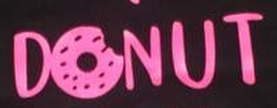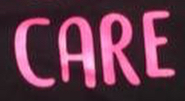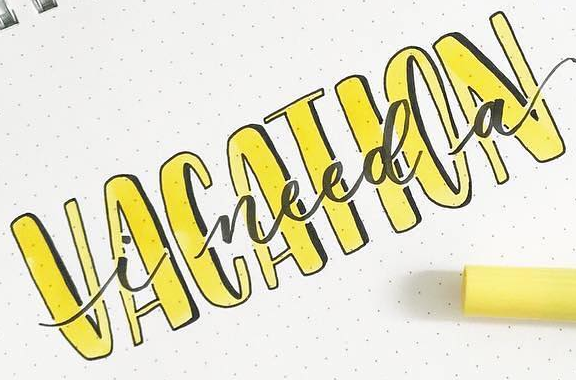What words are shown in these images in order, separated by a semicolon? DONUT; CARE; VACATION 